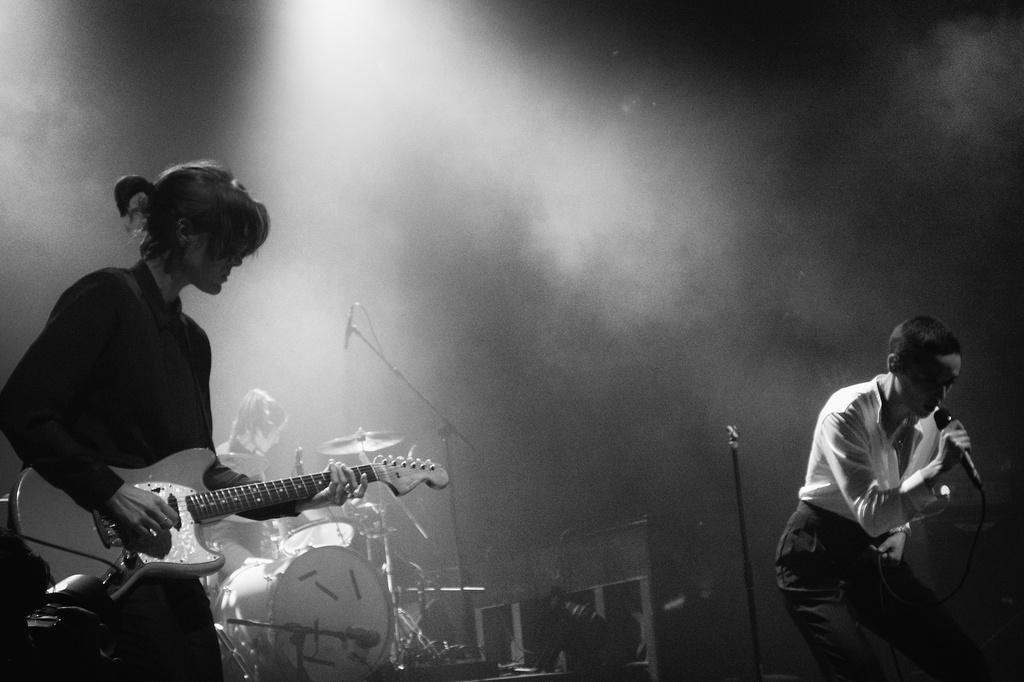What is the woman in the image doing? The woman is playing a guitar in the image. What else can be seen in the image besides the woman? There are musical instruments and a man in the image. What is the man in the image doing? The man is singing into a microphone in the image. How does the woman guide the furniture in the image? There is no furniture present in the image, and therefore the woman cannot guide any furniture. 